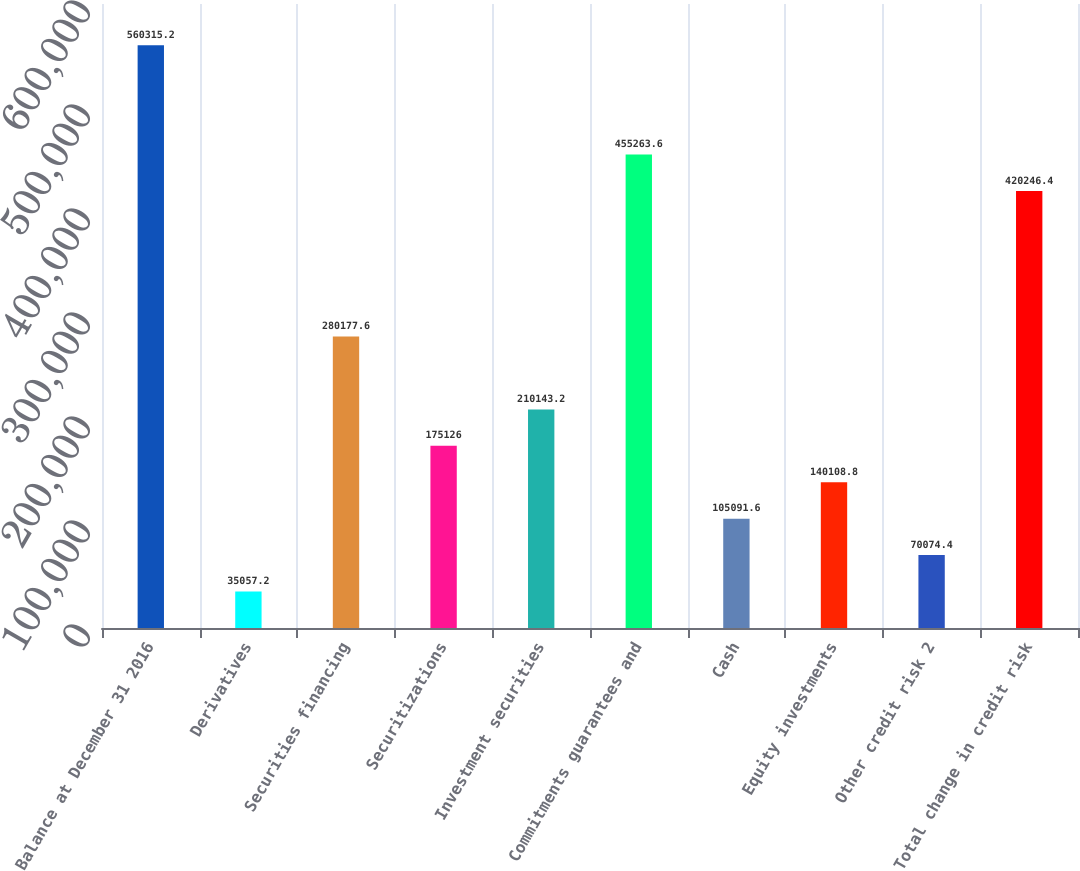Convert chart to OTSL. <chart><loc_0><loc_0><loc_500><loc_500><bar_chart><fcel>Balance at December 31 2016<fcel>Derivatives<fcel>Securities financing<fcel>Securitizations<fcel>Investment securities<fcel>Commitments guarantees and<fcel>Cash<fcel>Equity investments<fcel>Other credit risk 2<fcel>Total change in credit risk<nl><fcel>560315<fcel>35057.2<fcel>280178<fcel>175126<fcel>210143<fcel>455264<fcel>105092<fcel>140109<fcel>70074.4<fcel>420246<nl></chart> 